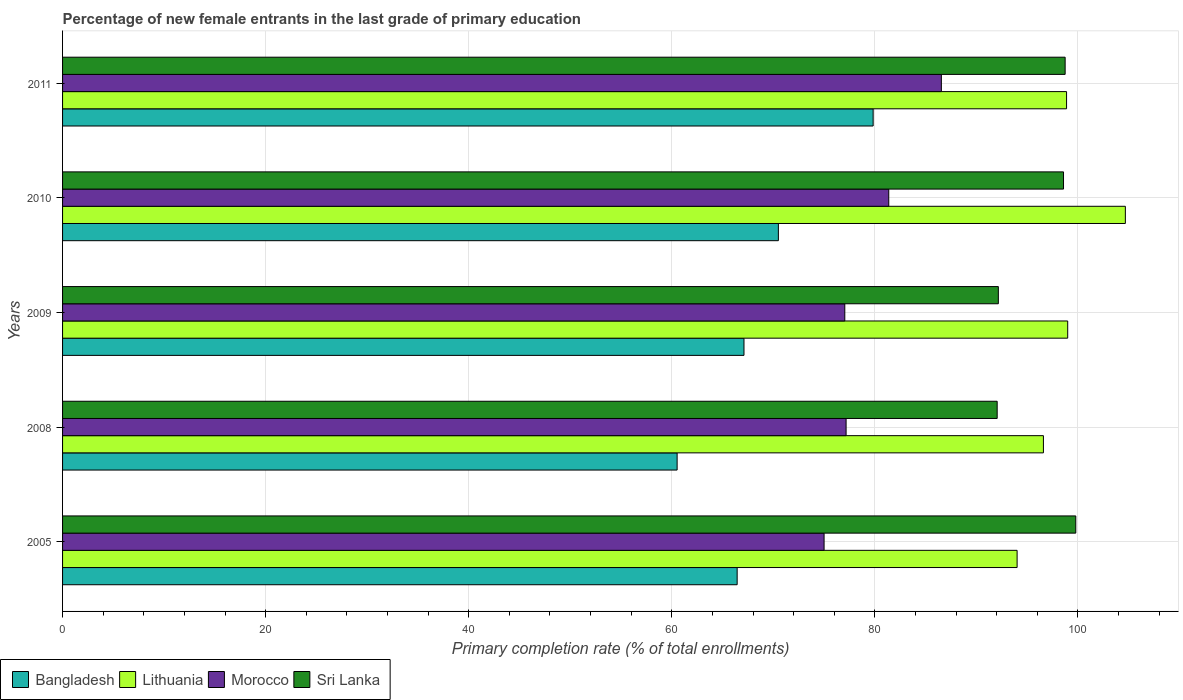How many bars are there on the 5th tick from the top?
Offer a terse response. 4. How many bars are there on the 5th tick from the bottom?
Offer a terse response. 4. What is the label of the 1st group of bars from the top?
Give a very brief answer. 2011. In how many cases, is the number of bars for a given year not equal to the number of legend labels?
Provide a short and direct response. 0. What is the percentage of new female entrants in Sri Lanka in 2011?
Keep it short and to the point. 98.74. Across all years, what is the maximum percentage of new female entrants in Morocco?
Provide a succinct answer. 86.55. Across all years, what is the minimum percentage of new female entrants in Morocco?
Provide a short and direct response. 75. In which year was the percentage of new female entrants in Bangladesh maximum?
Provide a succinct answer. 2011. In which year was the percentage of new female entrants in Morocco minimum?
Provide a short and direct response. 2005. What is the total percentage of new female entrants in Lithuania in the graph?
Provide a succinct answer. 493.16. What is the difference between the percentage of new female entrants in Sri Lanka in 2005 and that in 2009?
Keep it short and to the point. 7.63. What is the difference between the percentage of new female entrants in Lithuania in 2005 and the percentage of new female entrants in Morocco in 2008?
Keep it short and to the point. 16.84. What is the average percentage of new female entrants in Sri Lanka per year?
Your answer should be compact. 96.27. In the year 2005, what is the difference between the percentage of new female entrants in Sri Lanka and percentage of new female entrants in Lithuania?
Ensure brevity in your answer.  5.78. What is the ratio of the percentage of new female entrants in Bangladesh in 2009 to that in 2011?
Make the answer very short. 0.84. Is the percentage of new female entrants in Morocco in 2010 less than that in 2011?
Ensure brevity in your answer.  Yes. What is the difference between the highest and the second highest percentage of new female entrants in Bangladesh?
Ensure brevity in your answer.  9.33. What is the difference between the highest and the lowest percentage of new female entrants in Morocco?
Offer a very short reply. 11.55. In how many years, is the percentage of new female entrants in Bangladesh greater than the average percentage of new female entrants in Bangladesh taken over all years?
Your response must be concise. 2. Is the sum of the percentage of new female entrants in Morocco in 2008 and 2010 greater than the maximum percentage of new female entrants in Bangladesh across all years?
Your answer should be compact. Yes. Is it the case that in every year, the sum of the percentage of new female entrants in Sri Lanka and percentage of new female entrants in Lithuania is greater than the sum of percentage of new female entrants in Bangladesh and percentage of new female entrants in Morocco?
Your answer should be very brief. No. What does the 4th bar from the top in 2008 represents?
Provide a succinct answer. Bangladesh. What does the 2nd bar from the bottom in 2011 represents?
Provide a short and direct response. Lithuania. How many bars are there?
Your answer should be very brief. 20. Are all the bars in the graph horizontal?
Provide a succinct answer. Yes. What is the difference between two consecutive major ticks on the X-axis?
Give a very brief answer. 20. Does the graph contain grids?
Make the answer very short. Yes. Where does the legend appear in the graph?
Provide a short and direct response. Bottom left. How are the legend labels stacked?
Provide a short and direct response. Horizontal. What is the title of the graph?
Your answer should be compact. Percentage of new female entrants in the last grade of primary education. Does "Iceland" appear as one of the legend labels in the graph?
Your answer should be compact. No. What is the label or title of the X-axis?
Your answer should be compact. Primary completion rate (% of total enrollments). What is the label or title of the Y-axis?
Make the answer very short. Years. What is the Primary completion rate (% of total enrollments) in Bangladesh in 2005?
Give a very brief answer. 66.44. What is the Primary completion rate (% of total enrollments) of Lithuania in 2005?
Ensure brevity in your answer.  94.01. What is the Primary completion rate (% of total enrollments) in Morocco in 2005?
Your answer should be very brief. 75. What is the Primary completion rate (% of total enrollments) of Sri Lanka in 2005?
Provide a short and direct response. 99.79. What is the Primary completion rate (% of total enrollments) of Bangladesh in 2008?
Keep it short and to the point. 60.53. What is the Primary completion rate (% of total enrollments) in Lithuania in 2008?
Your answer should be very brief. 96.6. What is the Primary completion rate (% of total enrollments) of Morocco in 2008?
Give a very brief answer. 77.17. What is the Primary completion rate (% of total enrollments) of Sri Lanka in 2008?
Give a very brief answer. 92.05. What is the Primary completion rate (% of total enrollments) of Bangladesh in 2009?
Provide a short and direct response. 67.11. What is the Primary completion rate (% of total enrollments) in Lithuania in 2009?
Your answer should be compact. 98.99. What is the Primary completion rate (% of total enrollments) in Morocco in 2009?
Your answer should be very brief. 77.04. What is the Primary completion rate (% of total enrollments) of Sri Lanka in 2009?
Your answer should be compact. 92.16. What is the Primary completion rate (% of total enrollments) of Bangladesh in 2010?
Your answer should be very brief. 70.5. What is the Primary completion rate (% of total enrollments) in Lithuania in 2010?
Make the answer very short. 104.67. What is the Primary completion rate (% of total enrollments) in Morocco in 2010?
Ensure brevity in your answer.  81.37. What is the Primary completion rate (% of total enrollments) of Sri Lanka in 2010?
Ensure brevity in your answer.  98.58. What is the Primary completion rate (% of total enrollments) of Bangladesh in 2011?
Give a very brief answer. 79.83. What is the Primary completion rate (% of total enrollments) of Lithuania in 2011?
Keep it short and to the point. 98.88. What is the Primary completion rate (% of total enrollments) of Morocco in 2011?
Make the answer very short. 86.55. What is the Primary completion rate (% of total enrollments) in Sri Lanka in 2011?
Your answer should be compact. 98.74. Across all years, what is the maximum Primary completion rate (% of total enrollments) of Bangladesh?
Your response must be concise. 79.83. Across all years, what is the maximum Primary completion rate (% of total enrollments) in Lithuania?
Provide a short and direct response. 104.67. Across all years, what is the maximum Primary completion rate (% of total enrollments) in Morocco?
Provide a succinct answer. 86.55. Across all years, what is the maximum Primary completion rate (% of total enrollments) in Sri Lanka?
Keep it short and to the point. 99.79. Across all years, what is the minimum Primary completion rate (% of total enrollments) in Bangladesh?
Your response must be concise. 60.53. Across all years, what is the minimum Primary completion rate (% of total enrollments) of Lithuania?
Offer a terse response. 94.01. Across all years, what is the minimum Primary completion rate (% of total enrollments) of Morocco?
Offer a very short reply. 75. Across all years, what is the minimum Primary completion rate (% of total enrollments) of Sri Lanka?
Give a very brief answer. 92.05. What is the total Primary completion rate (% of total enrollments) of Bangladesh in the graph?
Provide a short and direct response. 344.41. What is the total Primary completion rate (% of total enrollments) of Lithuania in the graph?
Your answer should be very brief. 493.16. What is the total Primary completion rate (% of total enrollments) in Morocco in the graph?
Give a very brief answer. 397.13. What is the total Primary completion rate (% of total enrollments) in Sri Lanka in the graph?
Your response must be concise. 481.33. What is the difference between the Primary completion rate (% of total enrollments) in Bangladesh in 2005 and that in 2008?
Offer a very short reply. 5.91. What is the difference between the Primary completion rate (% of total enrollments) in Lithuania in 2005 and that in 2008?
Provide a succinct answer. -2.59. What is the difference between the Primary completion rate (% of total enrollments) of Morocco in 2005 and that in 2008?
Keep it short and to the point. -2.17. What is the difference between the Primary completion rate (% of total enrollments) of Sri Lanka in 2005 and that in 2008?
Your answer should be compact. 7.74. What is the difference between the Primary completion rate (% of total enrollments) of Bangladesh in 2005 and that in 2009?
Provide a succinct answer. -0.67. What is the difference between the Primary completion rate (% of total enrollments) of Lithuania in 2005 and that in 2009?
Offer a terse response. -4.98. What is the difference between the Primary completion rate (% of total enrollments) in Morocco in 2005 and that in 2009?
Give a very brief answer. -2.04. What is the difference between the Primary completion rate (% of total enrollments) of Sri Lanka in 2005 and that in 2009?
Provide a short and direct response. 7.63. What is the difference between the Primary completion rate (% of total enrollments) of Bangladesh in 2005 and that in 2010?
Your response must be concise. -4.06. What is the difference between the Primary completion rate (% of total enrollments) in Lithuania in 2005 and that in 2010?
Your response must be concise. -10.66. What is the difference between the Primary completion rate (% of total enrollments) of Morocco in 2005 and that in 2010?
Offer a terse response. -6.37. What is the difference between the Primary completion rate (% of total enrollments) in Sri Lanka in 2005 and that in 2010?
Keep it short and to the point. 1.21. What is the difference between the Primary completion rate (% of total enrollments) in Bangladesh in 2005 and that in 2011?
Your answer should be very brief. -13.39. What is the difference between the Primary completion rate (% of total enrollments) in Lithuania in 2005 and that in 2011?
Keep it short and to the point. -4.87. What is the difference between the Primary completion rate (% of total enrollments) in Morocco in 2005 and that in 2011?
Offer a very short reply. -11.55. What is the difference between the Primary completion rate (% of total enrollments) of Sri Lanka in 2005 and that in 2011?
Provide a short and direct response. 1.05. What is the difference between the Primary completion rate (% of total enrollments) of Bangladesh in 2008 and that in 2009?
Your response must be concise. -6.59. What is the difference between the Primary completion rate (% of total enrollments) of Lithuania in 2008 and that in 2009?
Provide a short and direct response. -2.39. What is the difference between the Primary completion rate (% of total enrollments) of Morocco in 2008 and that in 2009?
Your answer should be compact. 0.13. What is the difference between the Primary completion rate (% of total enrollments) of Sri Lanka in 2008 and that in 2009?
Make the answer very short. -0.12. What is the difference between the Primary completion rate (% of total enrollments) of Bangladesh in 2008 and that in 2010?
Keep it short and to the point. -9.97. What is the difference between the Primary completion rate (% of total enrollments) in Lithuania in 2008 and that in 2010?
Keep it short and to the point. -8.07. What is the difference between the Primary completion rate (% of total enrollments) in Morocco in 2008 and that in 2010?
Offer a terse response. -4.2. What is the difference between the Primary completion rate (% of total enrollments) of Sri Lanka in 2008 and that in 2010?
Your answer should be very brief. -6.53. What is the difference between the Primary completion rate (% of total enrollments) of Bangladesh in 2008 and that in 2011?
Your answer should be compact. -19.31. What is the difference between the Primary completion rate (% of total enrollments) of Lithuania in 2008 and that in 2011?
Give a very brief answer. -2.28. What is the difference between the Primary completion rate (% of total enrollments) in Morocco in 2008 and that in 2011?
Make the answer very short. -9.38. What is the difference between the Primary completion rate (% of total enrollments) in Sri Lanka in 2008 and that in 2011?
Your answer should be very brief. -6.69. What is the difference between the Primary completion rate (% of total enrollments) of Bangladesh in 2009 and that in 2010?
Make the answer very short. -3.39. What is the difference between the Primary completion rate (% of total enrollments) in Lithuania in 2009 and that in 2010?
Ensure brevity in your answer.  -5.68. What is the difference between the Primary completion rate (% of total enrollments) of Morocco in 2009 and that in 2010?
Your response must be concise. -4.33. What is the difference between the Primary completion rate (% of total enrollments) in Sri Lanka in 2009 and that in 2010?
Make the answer very short. -6.42. What is the difference between the Primary completion rate (% of total enrollments) in Bangladesh in 2009 and that in 2011?
Keep it short and to the point. -12.72. What is the difference between the Primary completion rate (% of total enrollments) of Lithuania in 2009 and that in 2011?
Offer a terse response. 0.11. What is the difference between the Primary completion rate (% of total enrollments) of Morocco in 2009 and that in 2011?
Provide a succinct answer. -9.51. What is the difference between the Primary completion rate (% of total enrollments) in Sri Lanka in 2009 and that in 2011?
Give a very brief answer. -6.58. What is the difference between the Primary completion rate (% of total enrollments) of Bangladesh in 2010 and that in 2011?
Your response must be concise. -9.33. What is the difference between the Primary completion rate (% of total enrollments) in Lithuania in 2010 and that in 2011?
Make the answer very short. 5.79. What is the difference between the Primary completion rate (% of total enrollments) of Morocco in 2010 and that in 2011?
Provide a short and direct response. -5.18. What is the difference between the Primary completion rate (% of total enrollments) of Sri Lanka in 2010 and that in 2011?
Provide a short and direct response. -0.16. What is the difference between the Primary completion rate (% of total enrollments) of Bangladesh in 2005 and the Primary completion rate (% of total enrollments) of Lithuania in 2008?
Give a very brief answer. -30.16. What is the difference between the Primary completion rate (% of total enrollments) of Bangladesh in 2005 and the Primary completion rate (% of total enrollments) of Morocco in 2008?
Offer a very short reply. -10.73. What is the difference between the Primary completion rate (% of total enrollments) of Bangladesh in 2005 and the Primary completion rate (% of total enrollments) of Sri Lanka in 2008?
Offer a very short reply. -25.61. What is the difference between the Primary completion rate (% of total enrollments) of Lithuania in 2005 and the Primary completion rate (% of total enrollments) of Morocco in 2008?
Offer a very short reply. 16.84. What is the difference between the Primary completion rate (% of total enrollments) in Lithuania in 2005 and the Primary completion rate (% of total enrollments) in Sri Lanka in 2008?
Provide a short and direct response. 1.96. What is the difference between the Primary completion rate (% of total enrollments) in Morocco in 2005 and the Primary completion rate (% of total enrollments) in Sri Lanka in 2008?
Ensure brevity in your answer.  -17.05. What is the difference between the Primary completion rate (% of total enrollments) in Bangladesh in 2005 and the Primary completion rate (% of total enrollments) in Lithuania in 2009?
Provide a succinct answer. -32.56. What is the difference between the Primary completion rate (% of total enrollments) in Bangladesh in 2005 and the Primary completion rate (% of total enrollments) in Morocco in 2009?
Provide a succinct answer. -10.6. What is the difference between the Primary completion rate (% of total enrollments) in Bangladesh in 2005 and the Primary completion rate (% of total enrollments) in Sri Lanka in 2009?
Your answer should be compact. -25.73. What is the difference between the Primary completion rate (% of total enrollments) of Lithuania in 2005 and the Primary completion rate (% of total enrollments) of Morocco in 2009?
Offer a terse response. 16.97. What is the difference between the Primary completion rate (% of total enrollments) of Lithuania in 2005 and the Primary completion rate (% of total enrollments) of Sri Lanka in 2009?
Your response must be concise. 1.85. What is the difference between the Primary completion rate (% of total enrollments) in Morocco in 2005 and the Primary completion rate (% of total enrollments) in Sri Lanka in 2009?
Offer a terse response. -17.16. What is the difference between the Primary completion rate (% of total enrollments) of Bangladesh in 2005 and the Primary completion rate (% of total enrollments) of Lithuania in 2010?
Your response must be concise. -38.23. What is the difference between the Primary completion rate (% of total enrollments) of Bangladesh in 2005 and the Primary completion rate (% of total enrollments) of Morocco in 2010?
Offer a terse response. -14.93. What is the difference between the Primary completion rate (% of total enrollments) in Bangladesh in 2005 and the Primary completion rate (% of total enrollments) in Sri Lanka in 2010?
Offer a terse response. -32.14. What is the difference between the Primary completion rate (% of total enrollments) of Lithuania in 2005 and the Primary completion rate (% of total enrollments) of Morocco in 2010?
Give a very brief answer. 12.64. What is the difference between the Primary completion rate (% of total enrollments) of Lithuania in 2005 and the Primary completion rate (% of total enrollments) of Sri Lanka in 2010?
Provide a short and direct response. -4.57. What is the difference between the Primary completion rate (% of total enrollments) in Morocco in 2005 and the Primary completion rate (% of total enrollments) in Sri Lanka in 2010?
Ensure brevity in your answer.  -23.58. What is the difference between the Primary completion rate (% of total enrollments) of Bangladesh in 2005 and the Primary completion rate (% of total enrollments) of Lithuania in 2011?
Your answer should be compact. -32.44. What is the difference between the Primary completion rate (% of total enrollments) in Bangladesh in 2005 and the Primary completion rate (% of total enrollments) in Morocco in 2011?
Your answer should be very brief. -20.11. What is the difference between the Primary completion rate (% of total enrollments) in Bangladesh in 2005 and the Primary completion rate (% of total enrollments) in Sri Lanka in 2011?
Provide a short and direct response. -32.3. What is the difference between the Primary completion rate (% of total enrollments) in Lithuania in 2005 and the Primary completion rate (% of total enrollments) in Morocco in 2011?
Offer a very short reply. 7.46. What is the difference between the Primary completion rate (% of total enrollments) of Lithuania in 2005 and the Primary completion rate (% of total enrollments) of Sri Lanka in 2011?
Give a very brief answer. -4.73. What is the difference between the Primary completion rate (% of total enrollments) in Morocco in 2005 and the Primary completion rate (% of total enrollments) in Sri Lanka in 2011?
Make the answer very short. -23.74. What is the difference between the Primary completion rate (% of total enrollments) of Bangladesh in 2008 and the Primary completion rate (% of total enrollments) of Lithuania in 2009?
Ensure brevity in your answer.  -38.47. What is the difference between the Primary completion rate (% of total enrollments) in Bangladesh in 2008 and the Primary completion rate (% of total enrollments) in Morocco in 2009?
Your response must be concise. -16.52. What is the difference between the Primary completion rate (% of total enrollments) of Bangladesh in 2008 and the Primary completion rate (% of total enrollments) of Sri Lanka in 2009?
Make the answer very short. -31.64. What is the difference between the Primary completion rate (% of total enrollments) of Lithuania in 2008 and the Primary completion rate (% of total enrollments) of Morocco in 2009?
Your response must be concise. 19.56. What is the difference between the Primary completion rate (% of total enrollments) in Lithuania in 2008 and the Primary completion rate (% of total enrollments) in Sri Lanka in 2009?
Make the answer very short. 4.44. What is the difference between the Primary completion rate (% of total enrollments) in Morocco in 2008 and the Primary completion rate (% of total enrollments) in Sri Lanka in 2009?
Offer a very short reply. -15. What is the difference between the Primary completion rate (% of total enrollments) of Bangladesh in 2008 and the Primary completion rate (% of total enrollments) of Lithuania in 2010?
Your answer should be very brief. -44.15. What is the difference between the Primary completion rate (% of total enrollments) of Bangladesh in 2008 and the Primary completion rate (% of total enrollments) of Morocco in 2010?
Provide a short and direct response. -20.84. What is the difference between the Primary completion rate (% of total enrollments) of Bangladesh in 2008 and the Primary completion rate (% of total enrollments) of Sri Lanka in 2010?
Give a very brief answer. -38.06. What is the difference between the Primary completion rate (% of total enrollments) in Lithuania in 2008 and the Primary completion rate (% of total enrollments) in Morocco in 2010?
Ensure brevity in your answer.  15.23. What is the difference between the Primary completion rate (% of total enrollments) of Lithuania in 2008 and the Primary completion rate (% of total enrollments) of Sri Lanka in 2010?
Your answer should be compact. -1.98. What is the difference between the Primary completion rate (% of total enrollments) in Morocco in 2008 and the Primary completion rate (% of total enrollments) in Sri Lanka in 2010?
Offer a very short reply. -21.41. What is the difference between the Primary completion rate (% of total enrollments) in Bangladesh in 2008 and the Primary completion rate (% of total enrollments) in Lithuania in 2011?
Offer a very short reply. -38.36. What is the difference between the Primary completion rate (% of total enrollments) in Bangladesh in 2008 and the Primary completion rate (% of total enrollments) in Morocco in 2011?
Offer a terse response. -26.03. What is the difference between the Primary completion rate (% of total enrollments) of Bangladesh in 2008 and the Primary completion rate (% of total enrollments) of Sri Lanka in 2011?
Provide a short and direct response. -38.22. What is the difference between the Primary completion rate (% of total enrollments) of Lithuania in 2008 and the Primary completion rate (% of total enrollments) of Morocco in 2011?
Offer a terse response. 10.05. What is the difference between the Primary completion rate (% of total enrollments) of Lithuania in 2008 and the Primary completion rate (% of total enrollments) of Sri Lanka in 2011?
Provide a succinct answer. -2.14. What is the difference between the Primary completion rate (% of total enrollments) in Morocco in 2008 and the Primary completion rate (% of total enrollments) in Sri Lanka in 2011?
Give a very brief answer. -21.57. What is the difference between the Primary completion rate (% of total enrollments) in Bangladesh in 2009 and the Primary completion rate (% of total enrollments) in Lithuania in 2010?
Your response must be concise. -37.56. What is the difference between the Primary completion rate (% of total enrollments) in Bangladesh in 2009 and the Primary completion rate (% of total enrollments) in Morocco in 2010?
Your response must be concise. -14.26. What is the difference between the Primary completion rate (% of total enrollments) in Bangladesh in 2009 and the Primary completion rate (% of total enrollments) in Sri Lanka in 2010?
Give a very brief answer. -31.47. What is the difference between the Primary completion rate (% of total enrollments) in Lithuania in 2009 and the Primary completion rate (% of total enrollments) in Morocco in 2010?
Provide a short and direct response. 17.62. What is the difference between the Primary completion rate (% of total enrollments) in Lithuania in 2009 and the Primary completion rate (% of total enrollments) in Sri Lanka in 2010?
Provide a short and direct response. 0.41. What is the difference between the Primary completion rate (% of total enrollments) in Morocco in 2009 and the Primary completion rate (% of total enrollments) in Sri Lanka in 2010?
Provide a short and direct response. -21.54. What is the difference between the Primary completion rate (% of total enrollments) in Bangladesh in 2009 and the Primary completion rate (% of total enrollments) in Lithuania in 2011?
Make the answer very short. -31.77. What is the difference between the Primary completion rate (% of total enrollments) of Bangladesh in 2009 and the Primary completion rate (% of total enrollments) of Morocco in 2011?
Give a very brief answer. -19.44. What is the difference between the Primary completion rate (% of total enrollments) of Bangladesh in 2009 and the Primary completion rate (% of total enrollments) of Sri Lanka in 2011?
Offer a very short reply. -31.63. What is the difference between the Primary completion rate (% of total enrollments) in Lithuania in 2009 and the Primary completion rate (% of total enrollments) in Morocco in 2011?
Make the answer very short. 12.44. What is the difference between the Primary completion rate (% of total enrollments) of Lithuania in 2009 and the Primary completion rate (% of total enrollments) of Sri Lanka in 2011?
Provide a short and direct response. 0.25. What is the difference between the Primary completion rate (% of total enrollments) of Morocco in 2009 and the Primary completion rate (% of total enrollments) of Sri Lanka in 2011?
Keep it short and to the point. -21.7. What is the difference between the Primary completion rate (% of total enrollments) in Bangladesh in 2010 and the Primary completion rate (% of total enrollments) in Lithuania in 2011?
Your answer should be very brief. -28.38. What is the difference between the Primary completion rate (% of total enrollments) in Bangladesh in 2010 and the Primary completion rate (% of total enrollments) in Morocco in 2011?
Keep it short and to the point. -16.05. What is the difference between the Primary completion rate (% of total enrollments) of Bangladesh in 2010 and the Primary completion rate (% of total enrollments) of Sri Lanka in 2011?
Offer a terse response. -28.24. What is the difference between the Primary completion rate (% of total enrollments) of Lithuania in 2010 and the Primary completion rate (% of total enrollments) of Morocco in 2011?
Keep it short and to the point. 18.12. What is the difference between the Primary completion rate (% of total enrollments) of Lithuania in 2010 and the Primary completion rate (% of total enrollments) of Sri Lanka in 2011?
Give a very brief answer. 5.93. What is the difference between the Primary completion rate (% of total enrollments) of Morocco in 2010 and the Primary completion rate (% of total enrollments) of Sri Lanka in 2011?
Give a very brief answer. -17.37. What is the average Primary completion rate (% of total enrollments) of Bangladesh per year?
Offer a very short reply. 68.88. What is the average Primary completion rate (% of total enrollments) of Lithuania per year?
Your answer should be very brief. 98.63. What is the average Primary completion rate (% of total enrollments) in Morocco per year?
Your response must be concise. 79.43. What is the average Primary completion rate (% of total enrollments) in Sri Lanka per year?
Provide a succinct answer. 96.27. In the year 2005, what is the difference between the Primary completion rate (% of total enrollments) of Bangladesh and Primary completion rate (% of total enrollments) of Lithuania?
Provide a succinct answer. -27.57. In the year 2005, what is the difference between the Primary completion rate (% of total enrollments) in Bangladesh and Primary completion rate (% of total enrollments) in Morocco?
Your answer should be very brief. -8.56. In the year 2005, what is the difference between the Primary completion rate (% of total enrollments) of Bangladesh and Primary completion rate (% of total enrollments) of Sri Lanka?
Give a very brief answer. -33.35. In the year 2005, what is the difference between the Primary completion rate (% of total enrollments) in Lithuania and Primary completion rate (% of total enrollments) in Morocco?
Your answer should be very brief. 19.01. In the year 2005, what is the difference between the Primary completion rate (% of total enrollments) in Lithuania and Primary completion rate (% of total enrollments) in Sri Lanka?
Give a very brief answer. -5.78. In the year 2005, what is the difference between the Primary completion rate (% of total enrollments) in Morocco and Primary completion rate (% of total enrollments) in Sri Lanka?
Your answer should be very brief. -24.79. In the year 2008, what is the difference between the Primary completion rate (% of total enrollments) in Bangladesh and Primary completion rate (% of total enrollments) in Lithuania?
Your response must be concise. -36.08. In the year 2008, what is the difference between the Primary completion rate (% of total enrollments) of Bangladesh and Primary completion rate (% of total enrollments) of Morocco?
Offer a very short reply. -16.64. In the year 2008, what is the difference between the Primary completion rate (% of total enrollments) in Bangladesh and Primary completion rate (% of total enrollments) in Sri Lanka?
Offer a terse response. -31.52. In the year 2008, what is the difference between the Primary completion rate (% of total enrollments) in Lithuania and Primary completion rate (% of total enrollments) in Morocco?
Offer a terse response. 19.43. In the year 2008, what is the difference between the Primary completion rate (% of total enrollments) of Lithuania and Primary completion rate (% of total enrollments) of Sri Lanka?
Keep it short and to the point. 4.55. In the year 2008, what is the difference between the Primary completion rate (% of total enrollments) of Morocco and Primary completion rate (% of total enrollments) of Sri Lanka?
Ensure brevity in your answer.  -14.88. In the year 2009, what is the difference between the Primary completion rate (% of total enrollments) in Bangladesh and Primary completion rate (% of total enrollments) in Lithuania?
Ensure brevity in your answer.  -31.88. In the year 2009, what is the difference between the Primary completion rate (% of total enrollments) of Bangladesh and Primary completion rate (% of total enrollments) of Morocco?
Your response must be concise. -9.93. In the year 2009, what is the difference between the Primary completion rate (% of total enrollments) in Bangladesh and Primary completion rate (% of total enrollments) in Sri Lanka?
Offer a terse response. -25.05. In the year 2009, what is the difference between the Primary completion rate (% of total enrollments) in Lithuania and Primary completion rate (% of total enrollments) in Morocco?
Keep it short and to the point. 21.95. In the year 2009, what is the difference between the Primary completion rate (% of total enrollments) of Lithuania and Primary completion rate (% of total enrollments) of Sri Lanka?
Ensure brevity in your answer.  6.83. In the year 2009, what is the difference between the Primary completion rate (% of total enrollments) in Morocco and Primary completion rate (% of total enrollments) in Sri Lanka?
Your response must be concise. -15.12. In the year 2010, what is the difference between the Primary completion rate (% of total enrollments) of Bangladesh and Primary completion rate (% of total enrollments) of Lithuania?
Your answer should be compact. -34.17. In the year 2010, what is the difference between the Primary completion rate (% of total enrollments) of Bangladesh and Primary completion rate (% of total enrollments) of Morocco?
Offer a terse response. -10.87. In the year 2010, what is the difference between the Primary completion rate (% of total enrollments) in Bangladesh and Primary completion rate (% of total enrollments) in Sri Lanka?
Provide a short and direct response. -28.08. In the year 2010, what is the difference between the Primary completion rate (% of total enrollments) of Lithuania and Primary completion rate (% of total enrollments) of Morocco?
Provide a short and direct response. 23.3. In the year 2010, what is the difference between the Primary completion rate (% of total enrollments) of Lithuania and Primary completion rate (% of total enrollments) of Sri Lanka?
Give a very brief answer. 6.09. In the year 2010, what is the difference between the Primary completion rate (% of total enrollments) in Morocco and Primary completion rate (% of total enrollments) in Sri Lanka?
Keep it short and to the point. -17.21. In the year 2011, what is the difference between the Primary completion rate (% of total enrollments) of Bangladesh and Primary completion rate (% of total enrollments) of Lithuania?
Give a very brief answer. -19.05. In the year 2011, what is the difference between the Primary completion rate (% of total enrollments) of Bangladesh and Primary completion rate (% of total enrollments) of Morocco?
Your response must be concise. -6.72. In the year 2011, what is the difference between the Primary completion rate (% of total enrollments) of Bangladesh and Primary completion rate (% of total enrollments) of Sri Lanka?
Ensure brevity in your answer.  -18.91. In the year 2011, what is the difference between the Primary completion rate (% of total enrollments) of Lithuania and Primary completion rate (% of total enrollments) of Morocco?
Make the answer very short. 12.33. In the year 2011, what is the difference between the Primary completion rate (% of total enrollments) in Lithuania and Primary completion rate (% of total enrollments) in Sri Lanka?
Offer a terse response. 0.14. In the year 2011, what is the difference between the Primary completion rate (% of total enrollments) in Morocco and Primary completion rate (% of total enrollments) in Sri Lanka?
Ensure brevity in your answer.  -12.19. What is the ratio of the Primary completion rate (% of total enrollments) of Bangladesh in 2005 to that in 2008?
Keep it short and to the point. 1.1. What is the ratio of the Primary completion rate (% of total enrollments) in Lithuania in 2005 to that in 2008?
Offer a terse response. 0.97. What is the ratio of the Primary completion rate (% of total enrollments) of Morocco in 2005 to that in 2008?
Provide a succinct answer. 0.97. What is the ratio of the Primary completion rate (% of total enrollments) of Sri Lanka in 2005 to that in 2008?
Your response must be concise. 1.08. What is the ratio of the Primary completion rate (% of total enrollments) of Bangladesh in 2005 to that in 2009?
Offer a very short reply. 0.99. What is the ratio of the Primary completion rate (% of total enrollments) of Lithuania in 2005 to that in 2009?
Offer a terse response. 0.95. What is the ratio of the Primary completion rate (% of total enrollments) of Morocco in 2005 to that in 2009?
Offer a very short reply. 0.97. What is the ratio of the Primary completion rate (% of total enrollments) of Sri Lanka in 2005 to that in 2009?
Offer a very short reply. 1.08. What is the ratio of the Primary completion rate (% of total enrollments) in Bangladesh in 2005 to that in 2010?
Offer a terse response. 0.94. What is the ratio of the Primary completion rate (% of total enrollments) of Lithuania in 2005 to that in 2010?
Give a very brief answer. 0.9. What is the ratio of the Primary completion rate (% of total enrollments) in Morocco in 2005 to that in 2010?
Provide a succinct answer. 0.92. What is the ratio of the Primary completion rate (% of total enrollments) in Sri Lanka in 2005 to that in 2010?
Give a very brief answer. 1.01. What is the ratio of the Primary completion rate (% of total enrollments) of Bangladesh in 2005 to that in 2011?
Provide a succinct answer. 0.83. What is the ratio of the Primary completion rate (% of total enrollments) of Lithuania in 2005 to that in 2011?
Give a very brief answer. 0.95. What is the ratio of the Primary completion rate (% of total enrollments) of Morocco in 2005 to that in 2011?
Provide a short and direct response. 0.87. What is the ratio of the Primary completion rate (% of total enrollments) in Sri Lanka in 2005 to that in 2011?
Your answer should be very brief. 1.01. What is the ratio of the Primary completion rate (% of total enrollments) of Bangladesh in 2008 to that in 2009?
Ensure brevity in your answer.  0.9. What is the ratio of the Primary completion rate (% of total enrollments) of Lithuania in 2008 to that in 2009?
Make the answer very short. 0.98. What is the ratio of the Primary completion rate (% of total enrollments) in Sri Lanka in 2008 to that in 2009?
Provide a succinct answer. 1. What is the ratio of the Primary completion rate (% of total enrollments) of Bangladesh in 2008 to that in 2010?
Offer a terse response. 0.86. What is the ratio of the Primary completion rate (% of total enrollments) in Lithuania in 2008 to that in 2010?
Make the answer very short. 0.92. What is the ratio of the Primary completion rate (% of total enrollments) in Morocco in 2008 to that in 2010?
Your answer should be very brief. 0.95. What is the ratio of the Primary completion rate (% of total enrollments) of Sri Lanka in 2008 to that in 2010?
Offer a very short reply. 0.93. What is the ratio of the Primary completion rate (% of total enrollments) of Bangladesh in 2008 to that in 2011?
Your answer should be compact. 0.76. What is the ratio of the Primary completion rate (% of total enrollments) in Lithuania in 2008 to that in 2011?
Your answer should be very brief. 0.98. What is the ratio of the Primary completion rate (% of total enrollments) of Morocco in 2008 to that in 2011?
Give a very brief answer. 0.89. What is the ratio of the Primary completion rate (% of total enrollments) of Sri Lanka in 2008 to that in 2011?
Your answer should be very brief. 0.93. What is the ratio of the Primary completion rate (% of total enrollments) in Bangladesh in 2009 to that in 2010?
Offer a very short reply. 0.95. What is the ratio of the Primary completion rate (% of total enrollments) in Lithuania in 2009 to that in 2010?
Your answer should be very brief. 0.95. What is the ratio of the Primary completion rate (% of total enrollments) of Morocco in 2009 to that in 2010?
Offer a very short reply. 0.95. What is the ratio of the Primary completion rate (% of total enrollments) in Sri Lanka in 2009 to that in 2010?
Provide a short and direct response. 0.93. What is the ratio of the Primary completion rate (% of total enrollments) of Bangladesh in 2009 to that in 2011?
Your answer should be very brief. 0.84. What is the ratio of the Primary completion rate (% of total enrollments) in Lithuania in 2009 to that in 2011?
Your answer should be very brief. 1. What is the ratio of the Primary completion rate (% of total enrollments) in Morocco in 2009 to that in 2011?
Offer a very short reply. 0.89. What is the ratio of the Primary completion rate (% of total enrollments) in Sri Lanka in 2009 to that in 2011?
Provide a short and direct response. 0.93. What is the ratio of the Primary completion rate (% of total enrollments) in Bangladesh in 2010 to that in 2011?
Your answer should be compact. 0.88. What is the ratio of the Primary completion rate (% of total enrollments) in Lithuania in 2010 to that in 2011?
Give a very brief answer. 1.06. What is the ratio of the Primary completion rate (% of total enrollments) of Morocco in 2010 to that in 2011?
Offer a very short reply. 0.94. What is the ratio of the Primary completion rate (% of total enrollments) of Sri Lanka in 2010 to that in 2011?
Your answer should be compact. 1. What is the difference between the highest and the second highest Primary completion rate (% of total enrollments) of Bangladesh?
Provide a short and direct response. 9.33. What is the difference between the highest and the second highest Primary completion rate (% of total enrollments) in Lithuania?
Provide a short and direct response. 5.68. What is the difference between the highest and the second highest Primary completion rate (% of total enrollments) of Morocco?
Make the answer very short. 5.18. What is the difference between the highest and the second highest Primary completion rate (% of total enrollments) of Sri Lanka?
Your answer should be compact. 1.05. What is the difference between the highest and the lowest Primary completion rate (% of total enrollments) of Bangladesh?
Your response must be concise. 19.31. What is the difference between the highest and the lowest Primary completion rate (% of total enrollments) of Lithuania?
Provide a short and direct response. 10.66. What is the difference between the highest and the lowest Primary completion rate (% of total enrollments) in Morocco?
Your response must be concise. 11.55. What is the difference between the highest and the lowest Primary completion rate (% of total enrollments) of Sri Lanka?
Make the answer very short. 7.74. 